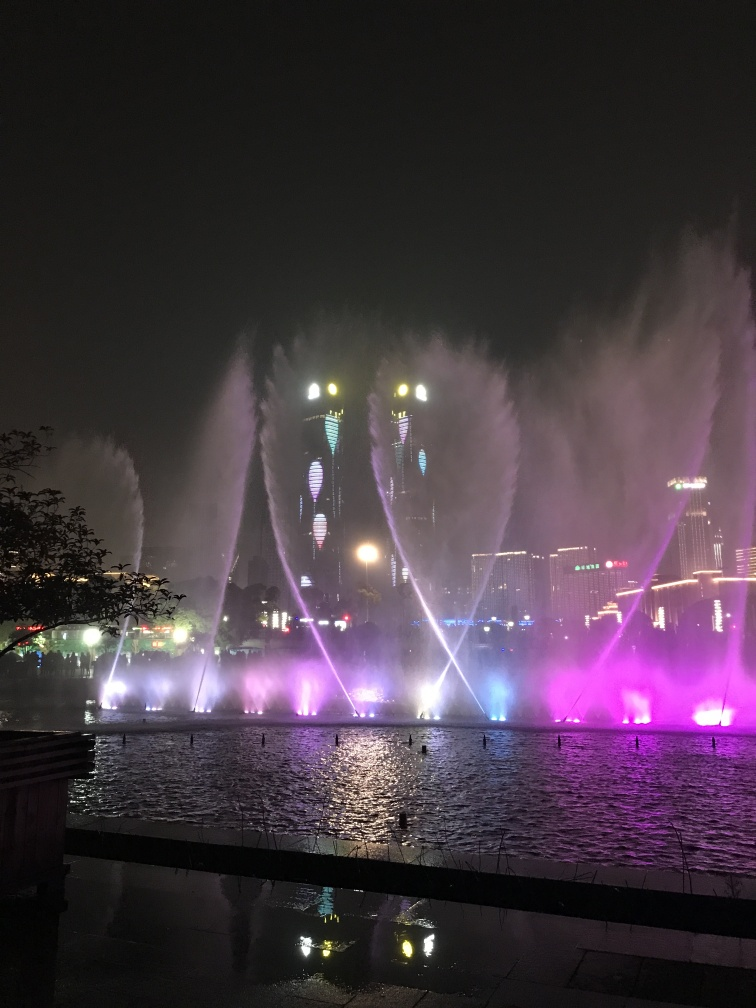What time of day was this photo taken? This photo was taken at night, as evidenced by the dark sky and the artificial lighting highlighting the fountains and surrounding architecture. 